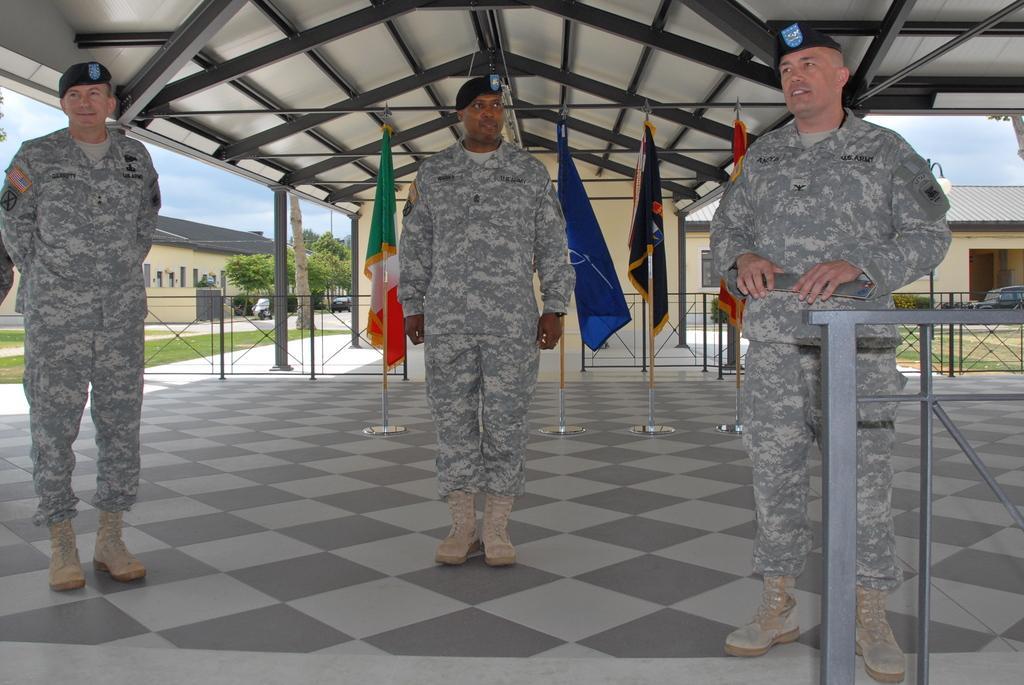In one or two sentences, can you explain what this image depicts? In this picture we can see three men wore caps, standing on the floor and smiling. At the back of them we can see flags, fences, roof and the grass. In the background we can see buildings, vehicles, plants, trees and the sky. 